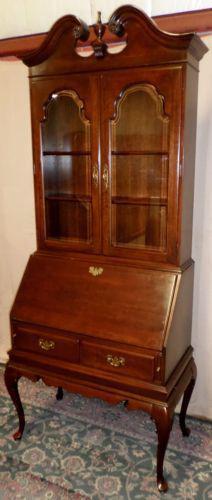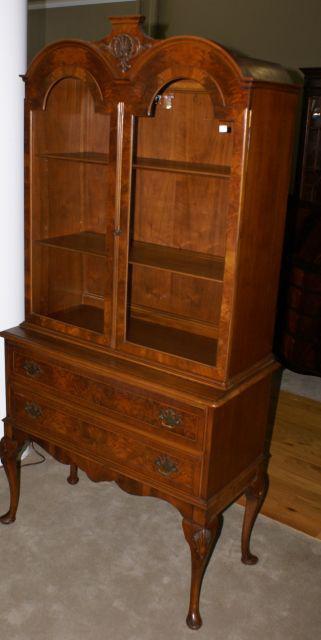The first image is the image on the left, the second image is the image on the right. Given the left and right images, does the statement "All wooden displays feature clear glass and are completely empty." hold true? Answer yes or no. Yes. The first image is the image on the left, the second image is the image on the right. Examine the images to the left and right. Is the description "Both images show just one cabinet with legs, and at least one cabinet has curving legs that end in a rounded foot." accurate? Answer yes or no. Yes. 